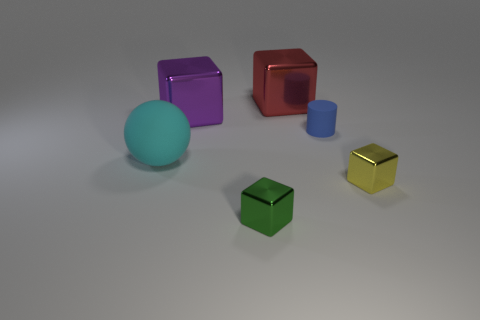What color is the other shiny thing that is the same size as the red metal thing?
Make the answer very short. Purple. Do the red metallic thing and the green metal object have the same shape?
Offer a terse response. Yes. There is a object that is both behind the yellow metal cube and in front of the tiny matte cylinder; what material is it?
Give a very brief answer. Rubber. The green metallic object is what size?
Your answer should be very brief. Small. What color is the other small object that is the same shape as the tiny yellow object?
Offer a terse response. Green. Are there any other things that are the same color as the ball?
Your answer should be very brief. No. There is a block behind the purple object; is its size the same as the rubber thing that is right of the cyan matte sphere?
Ensure brevity in your answer.  No. Are there an equal number of small blue matte objects that are behind the large purple cube and big red objects on the left side of the large ball?
Keep it short and to the point. Yes. Is the size of the purple shiny object the same as the matte thing on the left side of the purple shiny block?
Your response must be concise. Yes. There is a yellow metallic block in front of the purple block; is there a big rubber thing in front of it?
Give a very brief answer. No. 